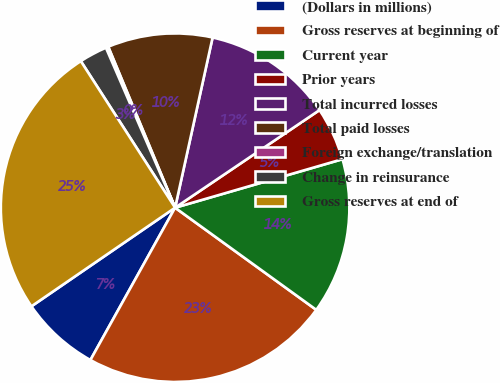Convert chart to OTSL. <chart><loc_0><loc_0><loc_500><loc_500><pie_chart><fcel>(Dollars in millions)<fcel>Gross reserves at beginning of<fcel>Current year<fcel>Prior years<fcel>Total incurred losses<fcel>Total paid losses<fcel>Foreign exchange/translation<fcel>Change in reinsurance<fcel>Gross reserves at end of<nl><fcel>7.35%<fcel>23.11%<fcel>14.46%<fcel>4.97%<fcel>12.09%<fcel>9.72%<fcel>0.23%<fcel>2.6%<fcel>25.48%<nl></chart> 